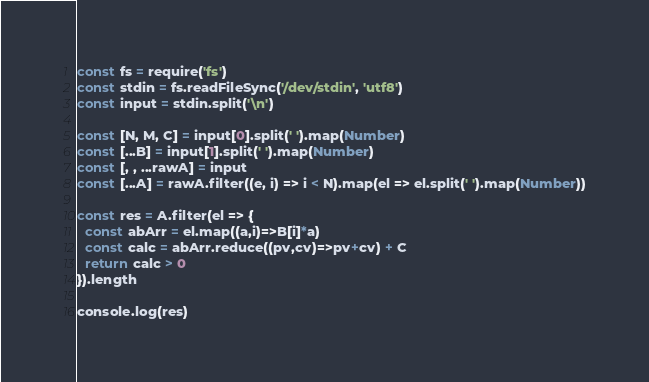Convert code to text. <code><loc_0><loc_0><loc_500><loc_500><_TypeScript_>const fs = require('fs')
const stdin = fs.readFileSync('/dev/stdin', 'utf8')
const input = stdin.split('\n')

const [N, M, C] = input[0].split(' ').map(Number)
const [...B] = input[1].split(' ').map(Number)
const [, , ...rawA] = input
const [...A] = rawA.filter((e, i) => i < N).map(el => el.split(' ').map(Number))

const res = A.filter(el => {
  const abArr = el.map((a,i)=>B[i]*a)
  const calc = abArr.reduce((pv,cv)=>pv+cv) + C
  return calc > 0
}).length

console.log(res)</code> 